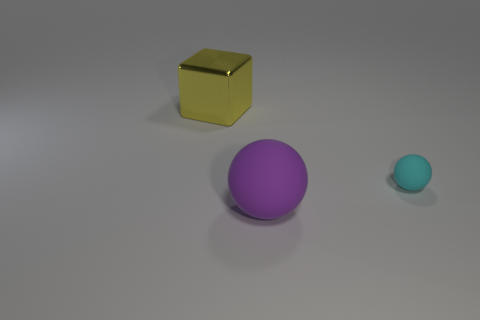Add 3 yellow metal cubes. How many objects exist? 6 Subtract 1 purple spheres. How many objects are left? 2 Subtract all balls. How many objects are left? 1 Subtract all small cyan objects. Subtract all large gray things. How many objects are left? 2 Add 3 small cyan balls. How many small cyan balls are left? 4 Add 3 small rubber things. How many small rubber things exist? 4 